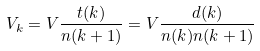Convert formula to latex. <formula><loc_0><loc_0><loc_500><loc_500>V _ { k } = V \frac { t ( k ) } { n ( k + 1 ) } = V \frac { d ( k ) } { n ( k ) n ( k + 1 ) }</formula> 